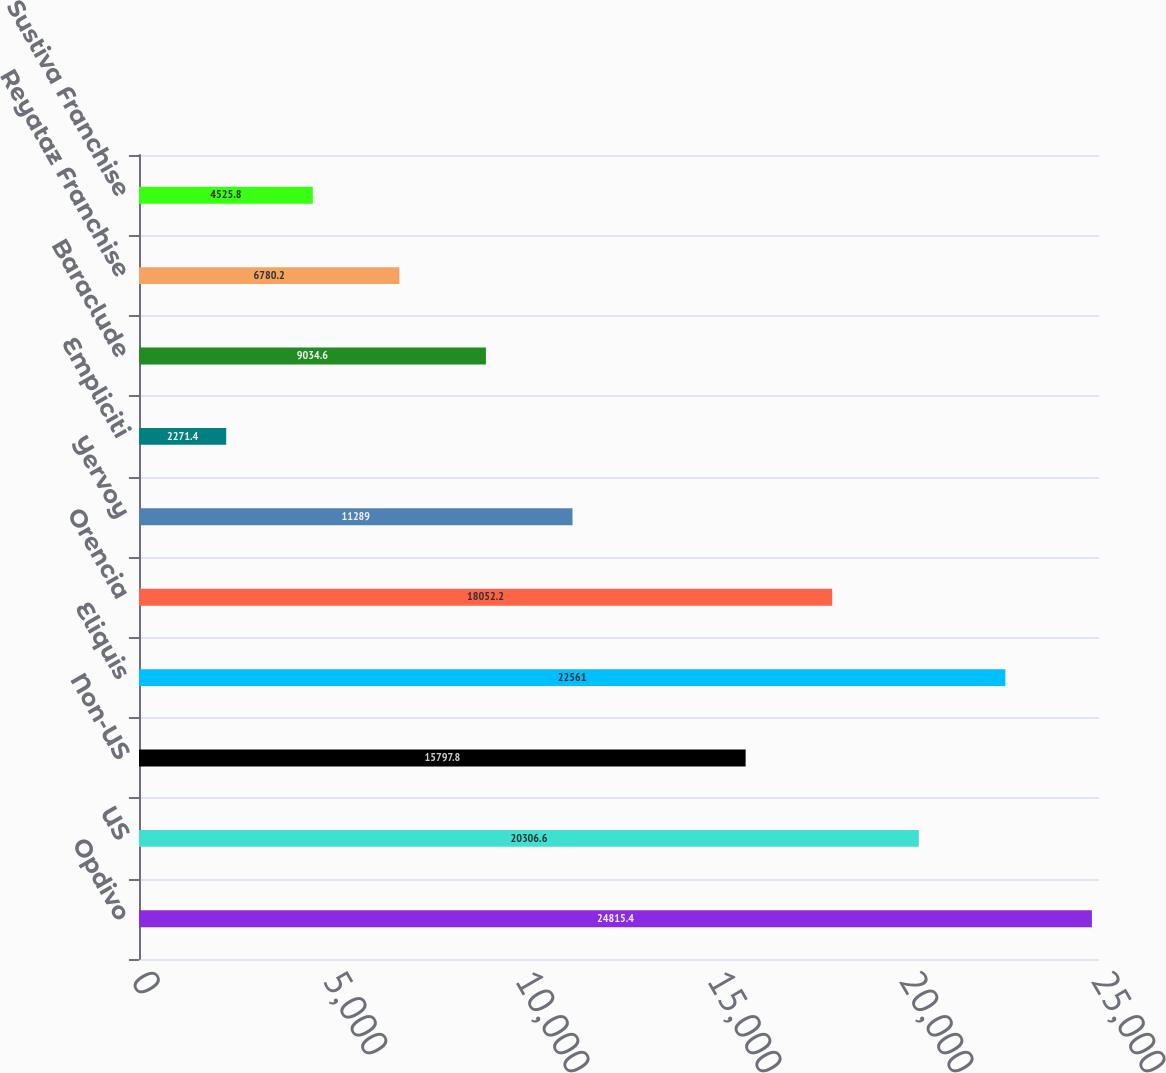Convert chart. <chart><loc_0><loc_0><loc_500><loc_500><bar_chart><fcel>Opdivo<fcel>US<fcel>Non-US<fcel>Eliquis<fcel>Orencia<fcel>Yervoy<fcel>Empliciti<fcel>Baraclude<fcel>Reyataz Franchise<fcel>Sustiva Franchise<nl><fcel>24815.4<fcel>20306.6<fcel>15797.8<fcel>22561<fcel>18052.2<fcel>11289<fcel>2271.4<fcel>9034.6<fcel>6780.2<fcel>4525.8<nl></chart> 